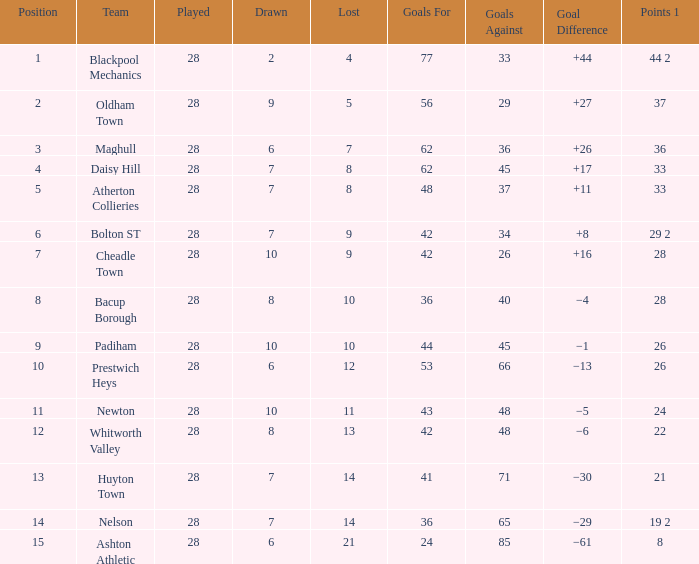What is the average played for entries with fewer than 65 goals against, points 1 of 19 2, and a position higher than 15? None. 